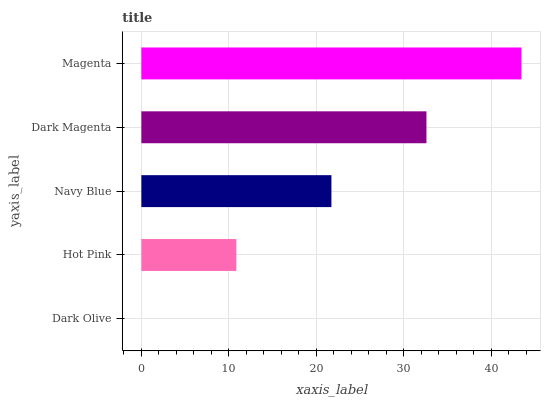Is Dark Olive the minimum?
Answer yes or no. Yes. Is Magenta the maximum?
Answer yes or no. Yes. Is Hot Pink the minimum?
Answer yes or no. No. Is Hot Pink the maximum?
Answer yes or no. No. Is Hot Pink greater than Dark Olive?
Answer yes or no. Yes. Is Dark Olive less than Hot Pink?
Answer yes or no. Yes. Is Dark Olive greater than Hot Pink?
Answer yes or no. No. Is Hot Pink less than Dark Olive?
Answer yes or no. No. Is Navy Blue the high median?
Answer yes or no. Yes. Is Navy Blue the low median?
Answer yes or no. Yes. Is Magenta the high median?
Answer yes or no. No. Is Dark Olive the low median?
Answer yes or no. No. 